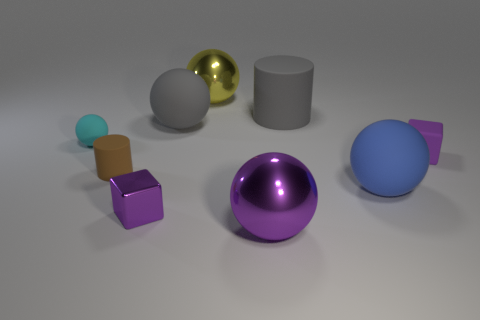Add 1 purple shiny blocks. How many objects exist? 10 Subtract all purple balls. How many balls are left? 4 Subtract all big blue rubber spheres. How many spheres are left? 4 Subtract all cylinders. How many objects are left? 7 Subtract 1 cylinders. How many cylinders are left? 1 Subtract all purple balls. Subtract all gray cylinders. How many balls are left? 4 Subtract all brown spheres. How many blue cylinders are left? 0 Subtract all small blue cylinders. Subtract all tiny brown matte cylinders. How many objects are left? 8 Add 3 large blue spheres. How many large blue spheres are left? 4 Add 7 tiny cubes. How many tiny cubes exist? 9 